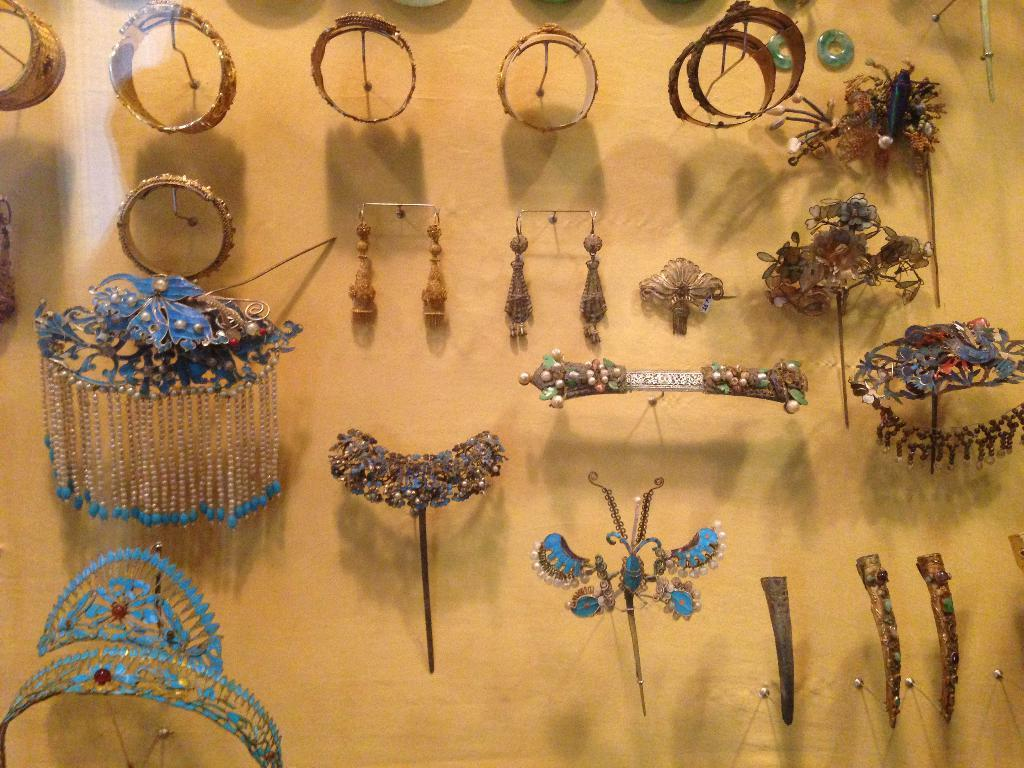What can be seen on the wall in the image? There are ornaments on the wall in the image. What type of vessel is being used for the voyage depicted in the image? There is no voyage or vessel present in the image; it only features ornaments on the wall. 